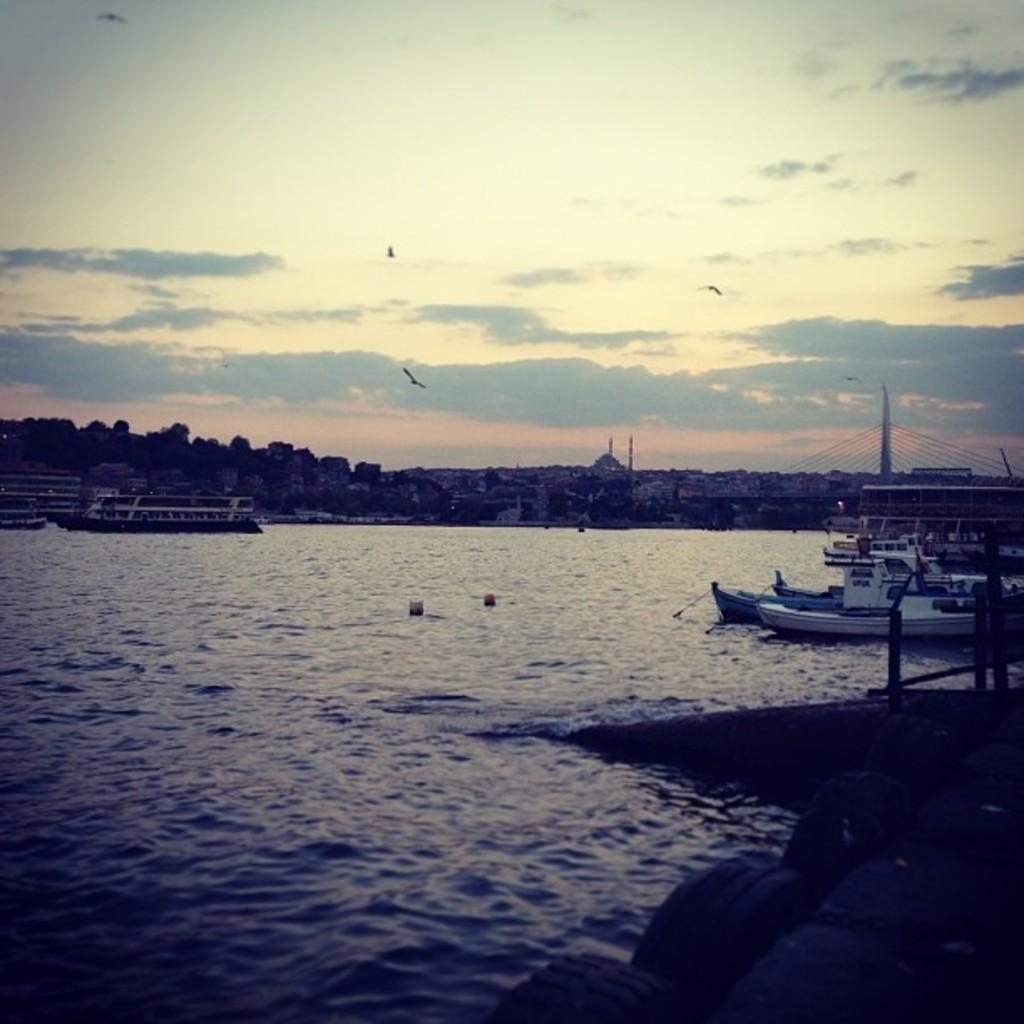What is the main subject in the center of the image? There are boats in the center of the image. What is located at the bottom of the image? There is water at the bottom of the image. What can be seen in the background of the image? There are trees and buildings in the background of the image. What is visible at the top of the image? There are birds and the sky visible at the top of the image. Where is the clam located in the image? There is no clam present in the image. What type of train can be seen passing by in the image? There is no train present in the image. 